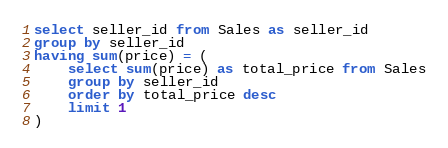<code> <loc_0><loc_0><loc_500><loc_500><_SQL_>select seller_id from Sales as seller_id
group by seller_id
having sum(price) = (
    select sum(price) as total_price from Sales
    group by seller_id
    order by total_price desc
    limit 1
)</code> 